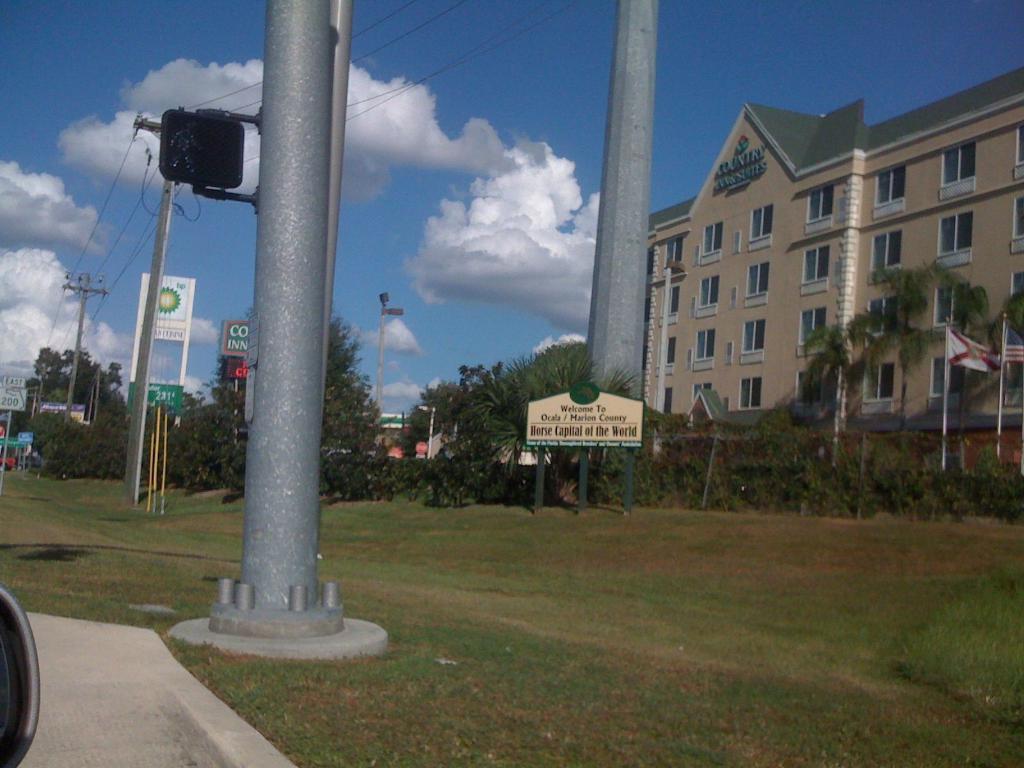How would you summarize this image in a sentence or two? In this image I can see an open grass ground and on it I can see number of poles, number of boards, few wires and on these boards I can see something is written. In the background I can see few buildings, clouds and the sky. On the right side of this image I can see few flags and on the bottom left side I can see a black colour thing. 